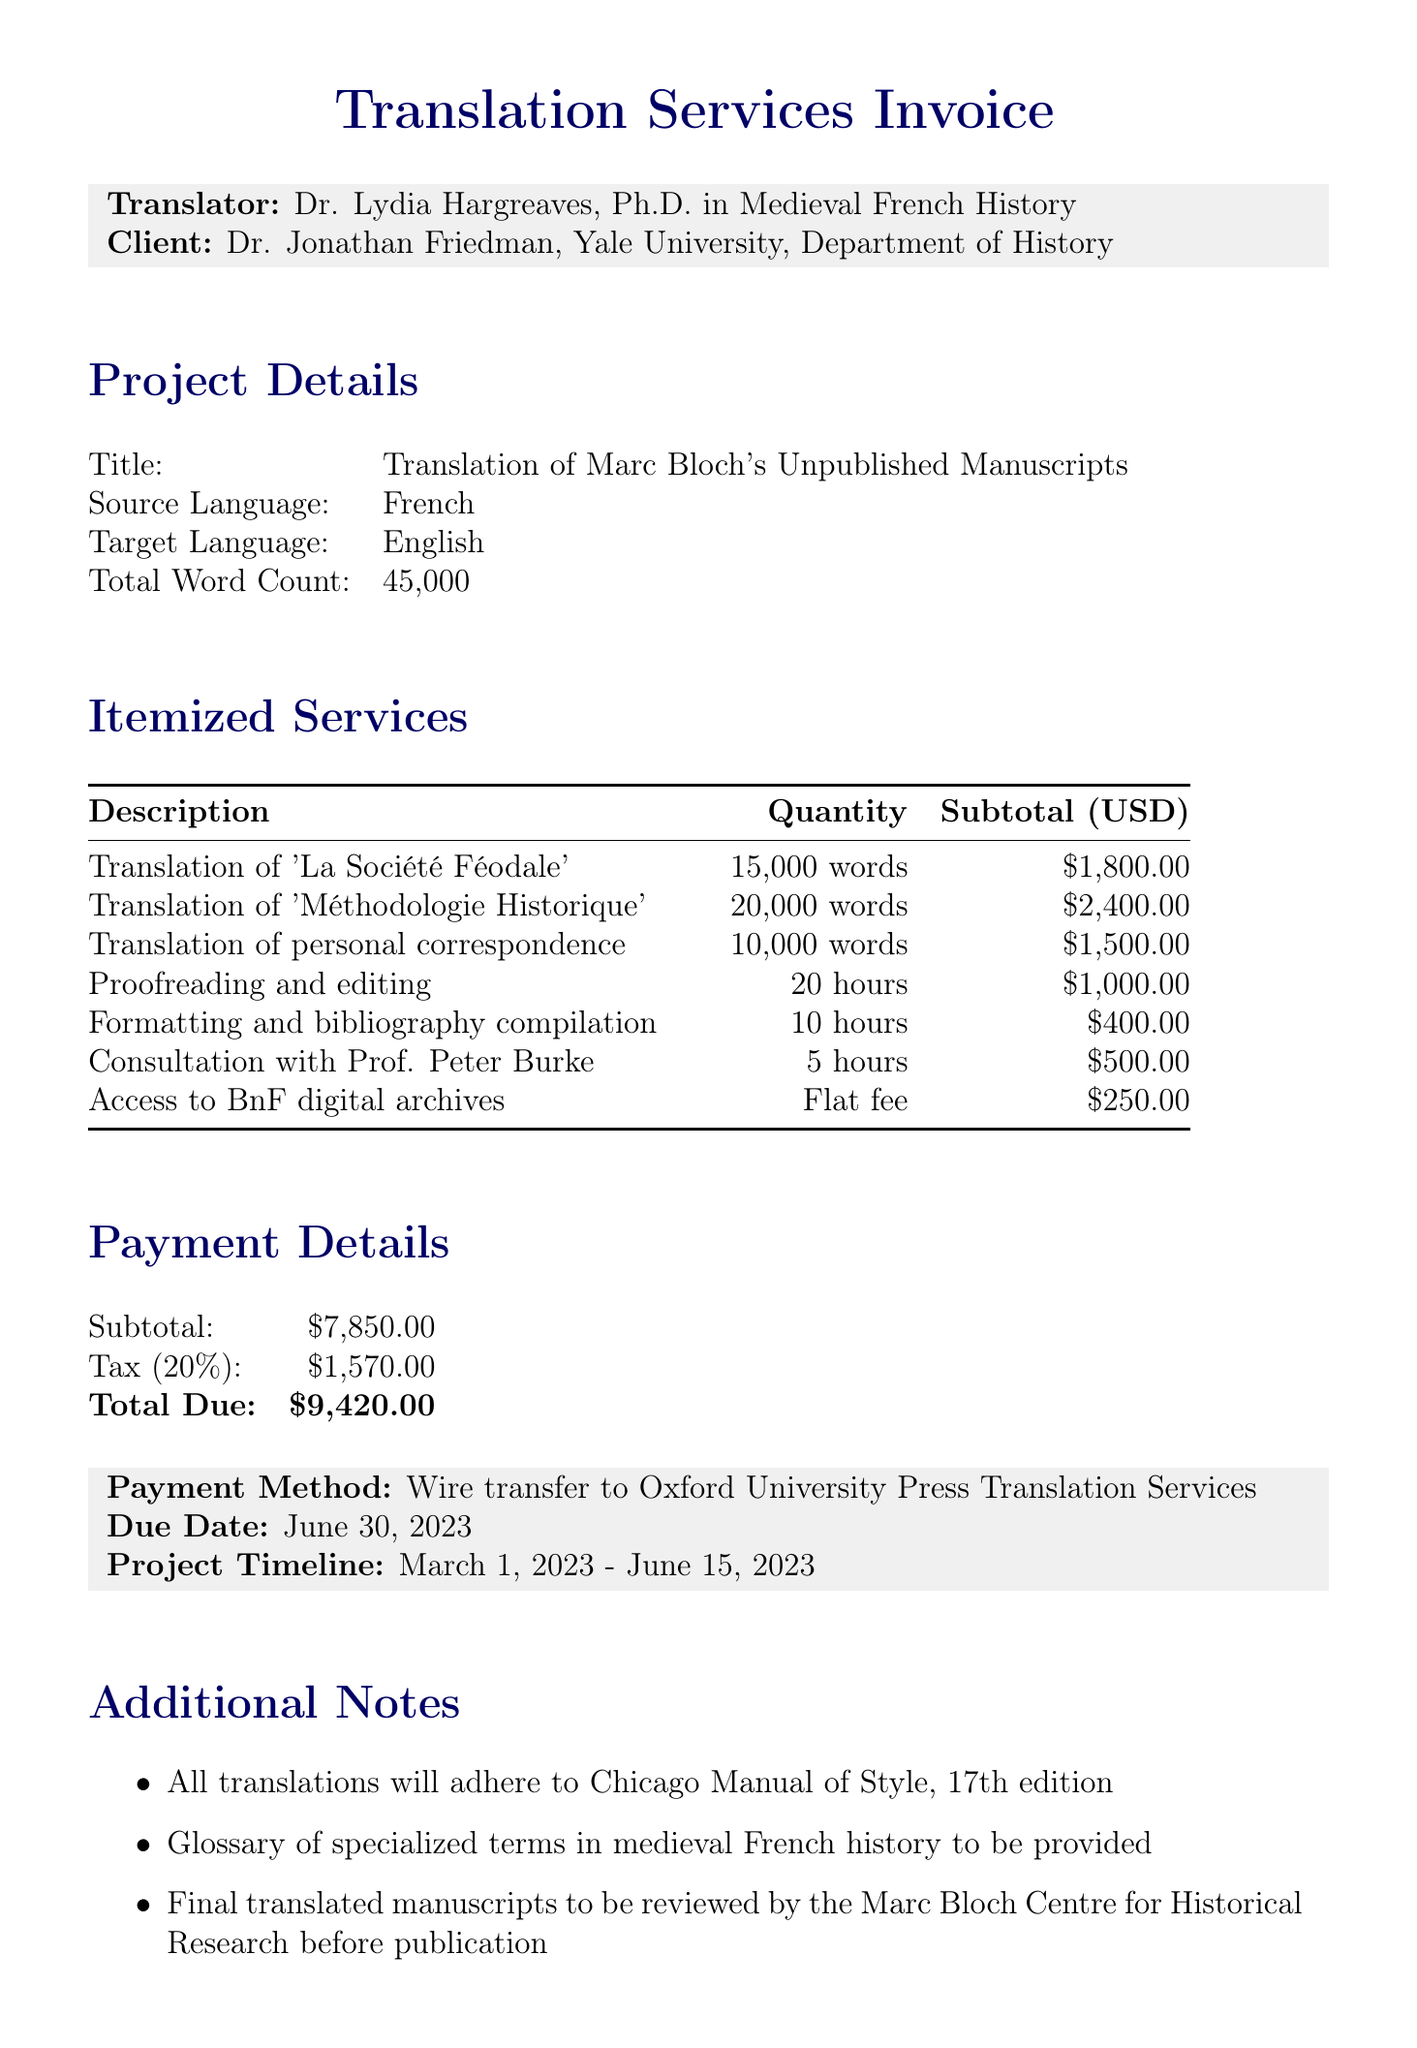What is the name of the translator? The document lists Dr. Lydia Hargreaves as the translator.
Answer: Dr. Lydia Hargreaves What is the total word count of the manuscripts? The project details specify that the total word count is 45,000 words.
Answer: 45,000 What is the payment due date? The payment details section mentions that the payment is due on June 30, 2023.
Answer: June 30, 2023 How much is the subtotal for the itemized services? The subtotal for itemized services is clearly stated as $7,850.00 in the payment details.
Answer: $7,850.00 What is the rate per word for translating 'Méthodologie Historique'? The document indicates that the rate per word for this service is $0.12.
Answer: $0.12 How many hours were allocated for proofreading and editing? The itemized services specify that 20 hours were allocated for proofreading and editing.
Answer: 20 hours What is the flat fee for access to the digital archives? The additional costs section shows that the flat fee for access is $250.00.
Answer: $250.00 Who was consulted regarding the Annales School expertise? The document mentions that the consultation was with Prof. Peter Burke.
Answer: Prof. Peter Burke 